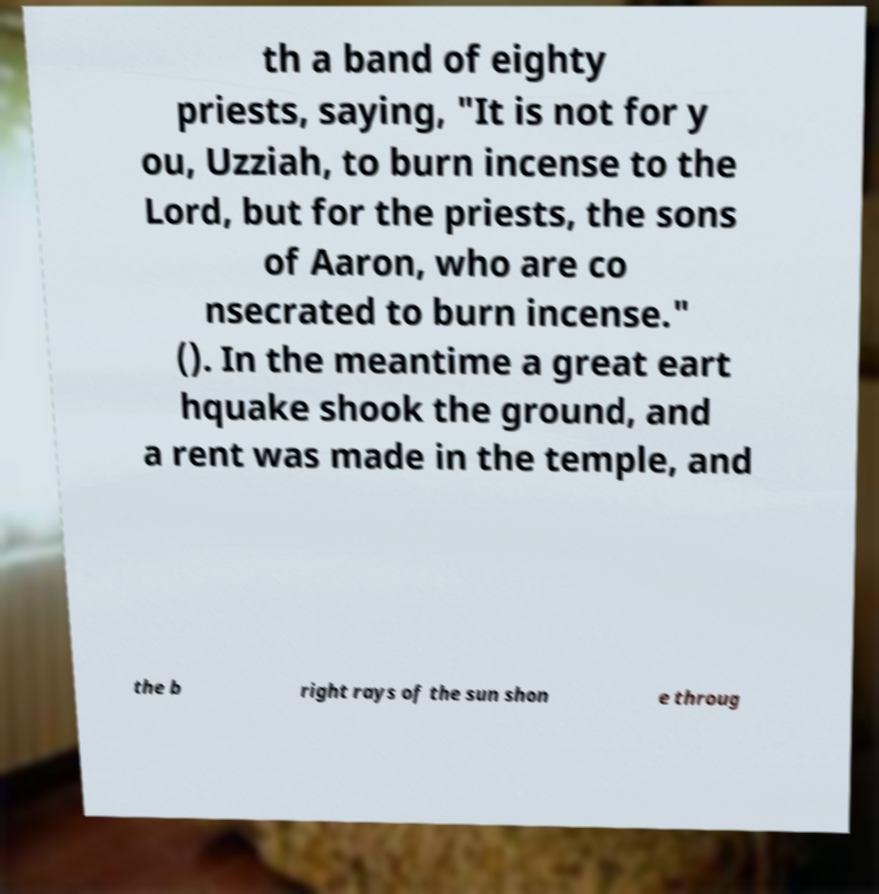Please read and relay the text visible in this image. What does it say? th a band of eighty priests, saying, "It is not for y ou, Uzziah, to burn incense to the Lord, but for the priests, the sons of Aaron, who are co nsecrated to burn incense." (). In the meantime a great eart hquake shook the ground, and a rent was made in the temple, and the b right rays of the sun shon e throug 